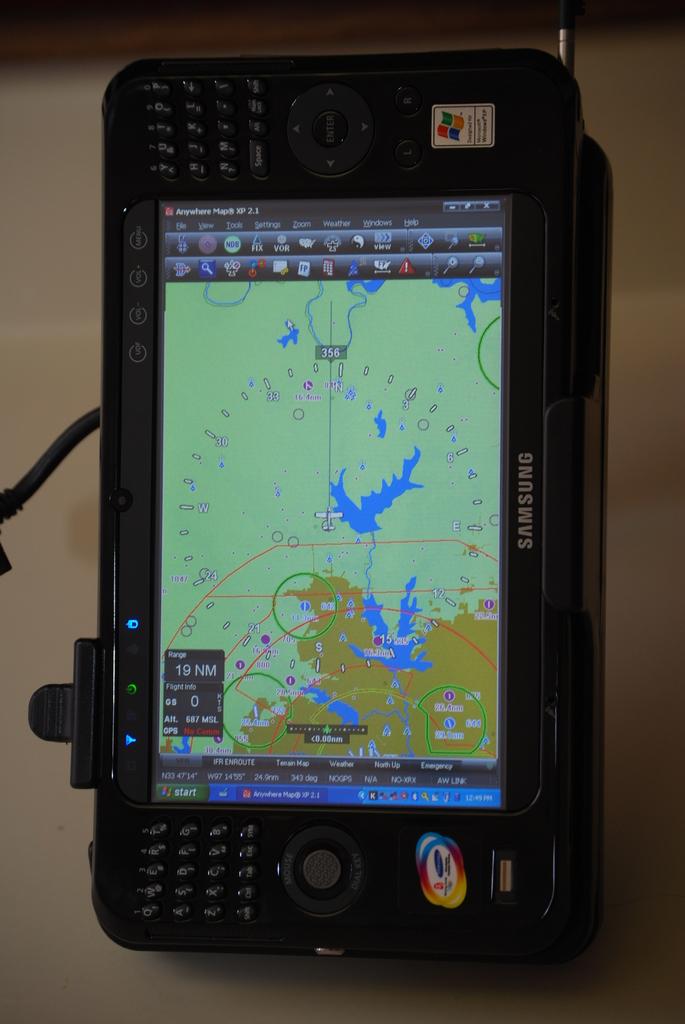Who is the maker of this device?
Provide a short and direct response. Samsung. 